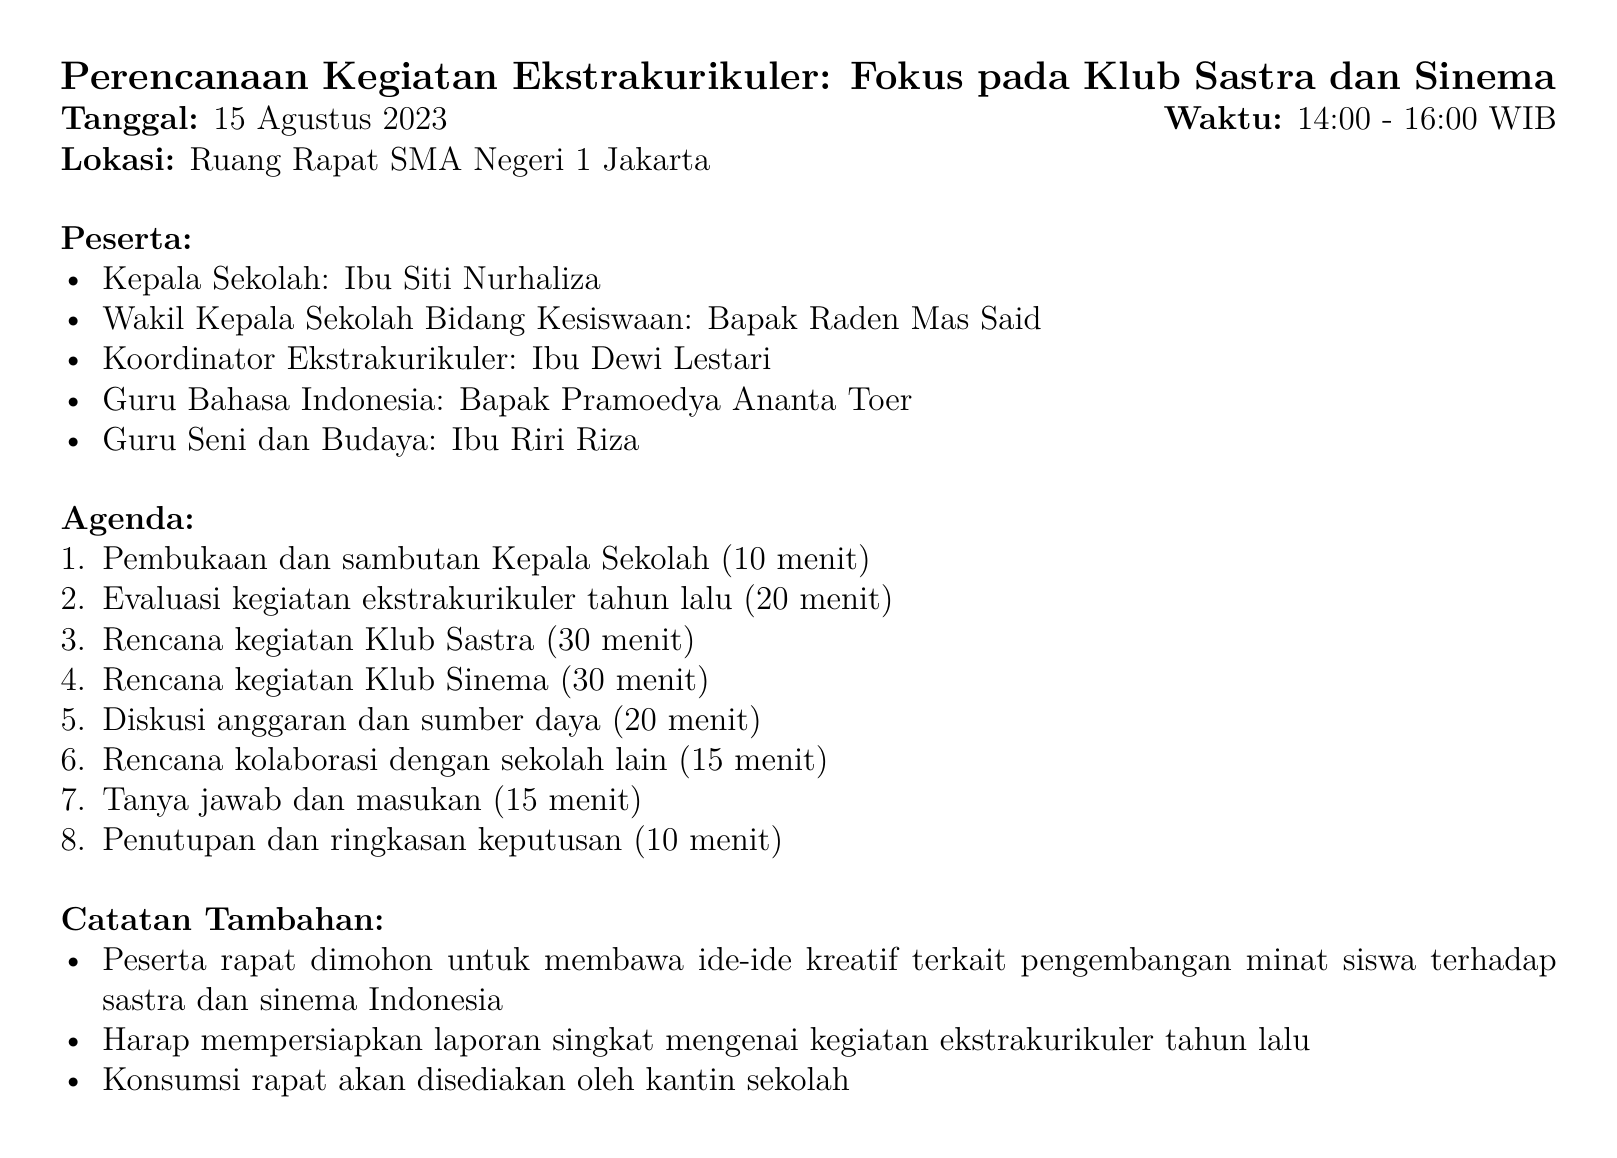What is the meeting title? The meeting title is mentioned at the beginning of the document.
Answer: Perencanaan Kegiatan Ekstrakurikuler: Fokus pada Klub Sastra dan Sinema When is the meeting scheduled? The date of the meeting is clearly stated in the document.
Answer: 15 Agustus 2023 Who is the coordinator of extracurricular activities? The document lists the attendees, which include the coordinator of extracurricular activities.
Answer: Ibu Dewi Lestari How many minutes are allocated for the opening and welcome speech? The duration for the opening speech is specified in the agenda items.
Answer: 10 menit What notable achievement did the Literature Club accomplish last year? The document includes specific achievements for the Literature Club in the evaluation section.
Answer: Juara 2 Lomba Cipta Puisi Tingkat Provinsi DKI Jakarta What activity is planned for the Literature Club regarding creative writing? The agenda includes various planned activities for the Literature Club, including writing workshops.
Answer: Workshop penulisan kreatif dengan penulis terkenal Which film director is mentioned for a workshop on filmmaking? The document specifies the names of individuals involved in planned activities, including a film director for a workshop.
Answer: Joko Anwar What is one planned collaborative project involving both clubs? The agenda lists planned activities that include collaboration between the Literature and Cinema clubs.
Answer: Adaptasi cerpen karya peserta Klub Sastra menjadi film pendek How long is the discussion on budget and resources scheduled for? The duration for the budget and resources discussion is included in the agenda items.
Answer: 20 menit 